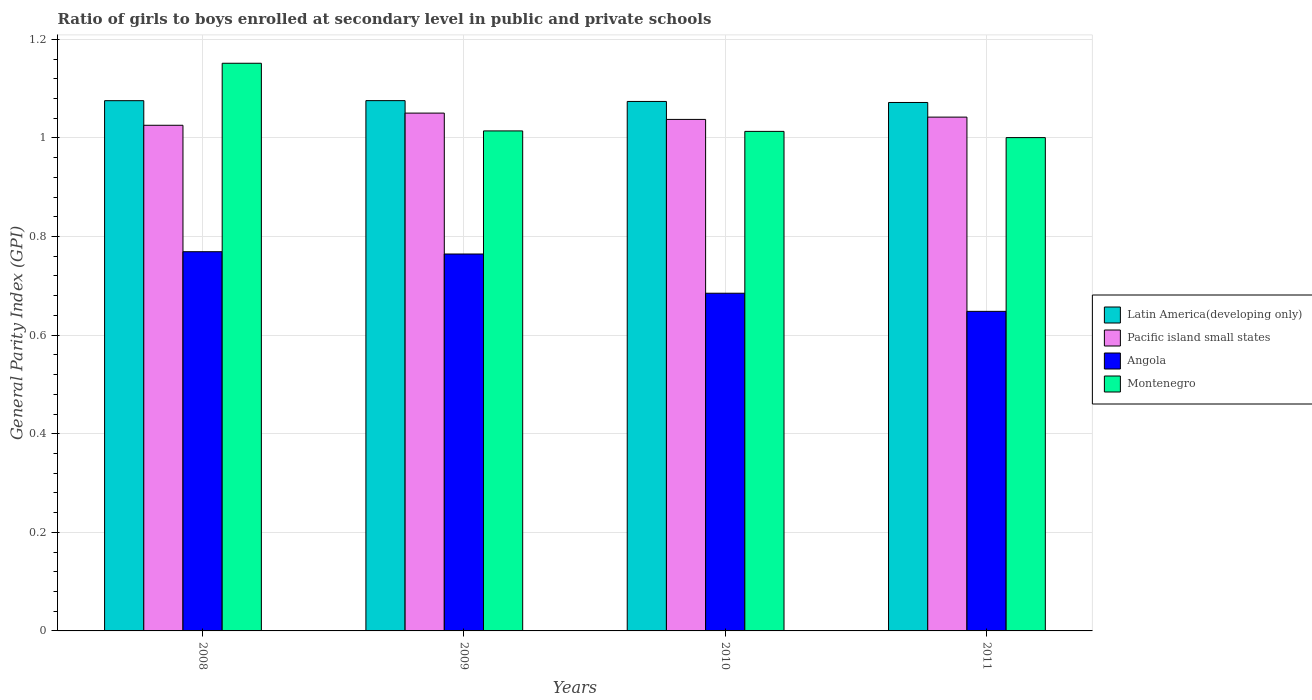Are the number of bars on each tick of the X-axis equal?
Give a very brief answer. Yes. How many bars are there on the 1st tick from the left?
Your response must be concise. 4. How many bars are there on the 3rd tick from the right?
Your answer should be compact. 4. What is the general parity index in Montenegro in 2011?
Make the answer very short. 1. Across all years, what is the maximum general parity index in Angola?
Keep it short and to the point. 0.77. Across all years, what is the minimum general parity index in Latin America(developing only)?
Your answer should be compact. 1.07. In which year was the general parity index in Angola minimum?
Your answer should be compact. 2011. What is the total general parity index in Pacific island small states in the graph?
Keep it short and to the point. 4.16. What is the difference between the general parity index in Montenegro in 2008 and that in 2009?
Your response must be concise. 0.14. What is the difference between the general parity index in Montenegro in 2008 and the general parity index in Angola in 2010?
Your answer should be compact. 0.47. What is the average general parity index in Latin America(developing only) per year?
Your response must be concise. 1.07. In the year 2010, what is the difference between the general parity index in Angola and general parity index in Latin America(developing only)?
Provide a short and direct response. -0.39. What is the ratio of the general parity index in Latin America(developing only) in 2008 to that in 2010?
Your answer should be very brief. 1. Is the difference between the general parity index in Angola in 2008 and 2010 greater than the difference between the general parity index in Latin America(developing only) in 2008 and 2010?
Offer a very short reply. Yes. What is the difference between the highest and the second highest general parity index in Montenegro?
Make the answer very short. 0.14. What is the difference between the highest and the lowest general parity index in Pacific island small states?
Your answer should be compact. 0.02. What does the 4th bar from the left in 2009 represents?
Make the answer very short. Montenegro. What does the 4th bar from the right in 2009 represents?
Provide a succinct answer. Latin America(developing only). How many bars are there?
Your response must be concise. 16. Are all the bars in the graph horizontal?
Your answer should be very brief. No. What is the difference between two consecutive major ticks on the Y-axis?
Provide a succinct answer. 0.2. Are the values on the major ticks of Y-axis written in scientific E-notation?
Your answer should be compact. No. Does the graph contain grids?
Provide a short and direct response. Yes. Where does the legend appear in the graph?
Provide a short and direct response. Center right. How many legend labels are there?
Your response must be concise. 4. What is the title of the graph?
Keep it short and to the point. Ratio of girls to boys enrolled at secondary level in public and private schools. What is the label or title of the X-axis?
Your answer should be compact. Years. What is the label or title of the Y-axis?
Keep it short and to the point. General Parity Index (GPI). What is the General Parity Index (GPI) in Latin America(developing only) in 2008?
Provide a short and direct response. 1.08. What is the General Parity Index (GPI) of Pacific island small states in 2008?
Your answer should be compact. 1.03. What is the General Parity Index (GPI) in Angola in 2008?
Offer a terse response. 0.77. What is the General Parity Index (GPI) of Montenegro in 2008?
Your answer should be compact. 1.15. What is the General Parity Index (GPI) of Latin America(developing only) in 2009?
Your answer should be compact. 1.08. What is the General Parity Index (GPI) in Pacific island small states in 2009?
Keep it short and to the point. 1.05. What is the General Parity Index (GPI) of Angola in 2009?
Your response must be concise. 0.76. What is the General Parity Index (GPI) of Montenegro in 2009?
Offer a terse response. 1.01. What is the General Parity Index (GPI) of Latin America(developing only) in 2010?
Your answer should be compact. 1.07. What is the General Parity Index (GPI) of Pacific island small states in 2010?
Give a very brief answer. 1.04. What is the General Parity Index (GPI) of Angola in 2010?
Ensure brevity in your answer.  0.68. What is the General Parity Index (GPI) of Montenegro in 2010?
Offer a terse response. 1.01. What is the General Parity Index (GPI) in Latin America(developing only) in 2011?
Provide a short and direct response. 1.07. What is the General Parity Index (GPI) of Pacific island small states in 2011?
Give a very brief answer. 1.04. What is the General Parity Index (GPI) of Angola in 2011?
Provide a succinct answer. 0.65. What is the General Parity Index (GPI) in Montenegro in 2011?
Your answer should be very brief. 1. Across all years, what is the maximum General Parity Index (GPI) in Latin America(developing only)?
Ensure brevity in your answer.  1.08. Across all years, what is the maximum General Parity Index (GPI) in Pacific island small states?
Your response must be concise. 1.05. Across all years, what is the maximum General Parity Index (GPI) in Angola?
Your response must be concise. 0.77. Across all years, what is the maximum General Parity Index (GPI) of Montenegro?
Your answer should be compact. 1.15. Across all years, what is the minimum General Parity Index (GPI) in Latin America(developing only)?
Offer a terse response. 1.07. Across all years, what is the minimum General Parity Index (GPI) of Pacific island small states?
Give a very brief answer. 1.03. Across all years, what is the minimum General Parity Index (GPI) of Angola?
Provide a short and direct response. 0.65. Across all years, what is the minimum General Parity Index (GPI) of Montenegro?
Provide a short and direct response. 1. What is the total General Parity Index (GPI) of Latin America(developing only) in the graph?
Offer a very short reply. 4.3. What is the total General Parity Index (GPI) in Pacific island small states in the graph?
Give a very brief answer. 4.16. What is the total General Parity Index (GPI) in Angola in the graph?
Your answer should be very brief. 2.87. What is the total General Parity Index (GPI) in Montenegro in the graph?
Your answer should be very brief. 4.18. What is the difference between the General Parity Index (GPI) in Latin America(developing only) in 2008 and that in 2009?
Offer a very short reply. -0. What is the difference between the General Parity Index (GPI) in Pacific island small states in 2008 and that in 2009?
Your response must be concise. -0.02. What is the difference between the General Parity Index (GPI) in Angola in 2008 and that in 2009?
Provide a succinct answer. 0. What is the difference between the General Parity Index (GPI) of Montenegro in 2008 and that in 2009?
Offer a terse response. 0.14. What is the difference between the General Parity Index (GPI) of Latin America(developing only) in 2008 and that in 2010?
Give a very brief answer. 0. What is the difference between the General Parity Index (GPI) of Pacific island small states in 2008 and that in 2010?
Give a very brief answer. -0.01. What is the difference between the General Parity Index (GPI) in Angola in 2008 and that in 2010?
Keep it short and to the point. 0.08. What is the difference between the General Parity Index (GPI) in Montenegro in 2008 and that in 2010?
Offer a very short reply. 0.14. What is the difference between the General Parity Index (GPI) of Latin America(developing only) in 2008 and that in 2011?
Offer a very short reply. 0. What is the difference between the General Parity Index (GPI) of Pacific island small states in 2008 and that in 2011?
Ensure brevity in your answer.  -0.02. What is the difference between the General Parity Index (GPI) in Angola in 2008 and that in 2011?
Your answer should be compact. 0.12. What is the difference between the General Parity Index (GPI) of Montenegro in 2008 and that in 2011?
Keep it short and to the point. 0.15. What is the difference between the General Parity Index (GPI) in Latin America(developing only) in 2009 and that in 2010?
Give a very brief answer. 0. What is the difference between the General Parity Index (GPI) in Pacific island small states in 2009 and that in 2010?
Your response must be concise. 0.01. What is the difference between the General Parity Index (GPI) of Angola in 2009 and that in 2010?
Give a very brief answer. 0.08. What is the difference between the General Parity Index (GPI) of Latin America(developing only) in 2009 and that in 2011?
Make the answer very short. 0. What is the difference between the General Parity Index (GPI) in Pacific island small states in 2009 and that in 2011?
Ensure brevity in your answer.  0.01. What is the difference between the General Parity Index (GPI) in Angola in 2009 and that in 2011?
Offer a terse response. 0.12. What is the difference between the General Parity Index (GPI) in Montenegro in 2009 and that in 2011?
Offer a very short reply. 0.01. What is the difference between the General Parity Index (GPI) of Latin America(developing only) in 2010 and that in 2011?
Make the answer very short. 0. What is the difference between the General Parity Index (GPI) in Pacific island small states in 2010 and that in 2011?
Provide a short and direct response. -0. What is the difference between the General Parity Index (GPI) of Angola in 2010 and that in 2011?
Your answer should be compact. 0.04. What is the difference between the General Parity Index (GPI) of Montenegro in 2010 and that in 2011?
Provide a short and direct response. 0.01. What is the difference between the General Parity Index (GPI) of Latin America(developing only) in 2008 and the General Parity Index (GPI) of Pacific island small states in 2009?
Keep it short and to the point. 0.03. What is the difference between the General Parity Index (GPI) in Latin America(developing only) in 2008 and the General Parity Index (GPI) in Angola in 2009?
Offer a very short reply. 0.31. What is the difference between the General Parity Index (GPI) in Latin America(developing only) in 2008 and the General Parity Index (GPI) in Montenegro in 2009?
Your answer should be compact. 0.06. What is the difference between the General Parity Index (GPI) in Pacific island small states in 2008 and the General Parity Index (GPI) in Angola in 2009?
Ensure brevity in your answer.  0.26. What is the difference between the General Parity Index (GPI) of Pacific island small states in 2008 and the General Parity Index (GPI) of Montenegro in 2009?
Your answer should be very brief. 0.01. What is the difference between the General Parity Index (GPI) of Angola in 2008 and the General Parity Index (GPI) of Montenegro in 2009?
Give a very brief answer. -0.24. What is the difference between the General Parity Index (GPI) of Latin America(developing only) in 2008 and the General Parity Index (GPI) of Pacific island small states in 2010?
Provide a succinct answer. 0.04. What is the difference between the General Parity Index (GPI) in Latin America(developing only) in 2008 and the General Parity Index (GPI) in Angola in 2010?
Offer a very short reply. 0.39. What is the difference between the General Parity Index (GPI) in Latin America(developing only) in 2008 and the General Parity Index (GPI) in Montenegro in 2010?
Ensure brevity in your answer.  0.06. What is the difference between the General Parity Index (GPI) of Pacific island small states in 2008 and the General Parity Index (GPI) of Angola in 2010?
Offer a very short reply. 0.34. What is the difference between the General Parity Index (GPI) in Pacific island small states in 2008 and the General Parity Index (GPI) in Montenegro in 2010?
Offer a terse response. 0.01. What is the difference between the General Parity Index (GPI) in Angola in 2008 and the General Parity Index (GPI) in Montenegro in 2010?
Provide a short and direct response. -0.24. What is the difference between the General Parity Index (GPI) in Latin America(developing only) in 2008 and the General Parity Index (GPI) in Pacific island small states in 2011?
Make the answer very short. 0.03. What is the difference between the General Parity Index (GPI) in Latin America(developing only) in 2008 and the General Parity Index (GPI) in Angola in 2011?
Your answer should be compact. 0.43. What is the difference between the General Parity Index (GPI) in Latin America(developing only) in 2008 and the General Parity Index (GPI) in Montenegro in 2011?
Your answer should be compact. 0.07. What is the difference between the General Parity Index (GPI) of Pacific island small states in 2008 and the General Parity Index (GPI) of Angola in 2011?
Offer a very short reply. 0.38. What is the difference between the General Parity Index (GPI) of Pacific island small states in 2008 and the General Parity Index (GPI) of Montenegro in 2011?
Provide a short and direct response. 0.03. What is the difference between the General Parity Index (GPI) in Angola in 2008 and the General Parity Index (GPI) in Montenegro in 2011?
Make the answer very short. -0.23. What is the difference between the General Parity Index (GPI) of Latin America(developing only) in 2009 and the General Parity Index (GPI) of Pacific island small states in 2010?
Offer a terse response. 0.04. What is the difference between the General Parity Index (GPI) in Latin America(developing only) in 2009 and the General Parity Index (GPI) in Angola in 2010?
Ensure brevity in your answer.  0.39. What is the difference between the General Parity Index (GPI) in Latin America(developing only) in 2009 and the General Parity Index (GPI) in Montenegro in 2010?
Offer a terse response. 0.06. What is the difference between the General Parity Index (GPI) of Pacific island small states in 2009 and the General Parity Index (GPI) of Angola in 2010?
Your answer should be very brief. 0.37. What is the difference between the General Parity Index (GPI) in Pacific island small states in 2009 and the General Parity Index (GPI) in Montenegro in 2010?
Provide a short and direct response. 0.04. What is the difference between the General Parity Index (GPI) in Angola in 2009 and the General Parity Index (GPI) in Montenegro in 2010?
Keep it short and to the point. -0.25. What is the difference between the General Parity Index (GPI) of Latin America(developing only) in 2009 and the General Parity Index (GPI) of Pacific island small states in 2011?
Provide a succinct answer. 0.03. What is the difference between the General Parity Index (GPI) in Latin America(developing only) in 2009 and the General Parity Index (GPI) in Angola in 2011?
Your answer should be compact. 0.43. What is the difference between the General Parity Index (GPI) of Latin America(developing only) in 2009 and the General Parity Index (GPI) of Montenegro in 2011?
Keep it short and to the point. 0.07. What is the difference between the General Parity Index (GPI) of Pacific island small states in 2009 and the General Parity Index (GPI) of Angola in 2011?
Ensure brevity in your answer.  0.4. What is the difference between the General Parity Index (GPI) in Pacific island small states in 2009 and the General Parity Index (GPI) in Montenegro in 2011?
Your answer should be very brief. 0.05. What is the difference between the General Parity Index (GPI) of Angola in 2009 and the General Parity Index (GPI) of Montenegro in 2011?
Provide a short and direct response. -0.24. What is the difference between the General Parity Index (GPI) of Latin America(developing only) in 2010 and the General Parity Index (GPI) of Pacific island small states in 2011?
Give a very brief answer. 0.03. What is the difference between the General Parity Index (GPI) in Latin America(developing only) in 2010 and the General Parity Index (GPI) in Angola in 2011?
Offer a very short reply. 0.43. What is the difference between the General Parity Index (GPI) in Latin America(developing only) in 2010 and the General Parity Index (GPI) in Montenegro in 2011?
Offer a terse response. 0.07. What is the difference between the General Parity Index (GPI) in Pacific island small states in 2010 and the General Parity Index (GPI) in Angola in 2011?
Make the answer very short. 0.39. What is the difference between the General Parity Index (GPI) in Pacific island small states in 2010 and the General Parity Index (GPI) in Montenegro in 2011?
Offer a terse response. 0.04. What is the difference between the General Parity Index (GPI) in Angola in 2010 and the General Parity Index (GPI) in Montenegro in 2011?
Provide a short and direct response. -0.32. What is the average General Parity Index (GPI) in Latin America(developing only) per year?
Make the answer very short. 1.07. What is the average General Parity Index (GPI) in Pacific island small states per year?
Give a very brief answer. 1.04. What is the average General Parity Index (GPI) of Angola per year?
Keep it short and to the point. 0.72. What is the average General Parity Index (GPI) of Montenegro per year?
Provide a short and direct response. 1.04. In the year 2008, what is the difference between the General Parity Index (GPI) in Latin America(developing only) and General Parity Index (GPI) in Pacific island small states?
Make the answer very short. 0.05. In the year 2008, what is the difference between the General Parity Index (GPI) in Latin America(developing only) and General Parity Index (GPI) in Angola?
Give a very brief answer. 0.31. In the year 2008, what is the difference between the General Parity Index (GPI) of Latin America(developing only) and General Parity Index (GPI) of Montenegro?
Offer a terse response. -0.08. In the year 2008, what is the difference between the General Parity Index (GPI) of Pacific island small states and General Parity Index (GPI) of Angola?
Offer a terse response. 0.26. In the year 2008, what is the difference between the General Parity Index (GPI) in Pacific island small states and General Parity Index (GPI) in Montenegro?
Your answer should be compact. -0.13. In the year 2008, what is the difference between the General Parity Index (GPI) of Angola and General Parity Index (GPI) of Montenegro?
Your answer should be compact. -0.38. In the year 2009, what is the difference between the General Parity Index (GPI) in Latin America(developing only) and General Parity Index (GPI) in Pacific island small states?
Give a very brief answer. 0.03. In the year 2009, what is the difference between the General Parity Index (GPI) of Latin America(developing only) and General Parity Index (GPI) of Angola?
Offer a very short reply. 0.31. In the year 2009, what is the difference between the General Parity Index (GPI) in Latin America(developing only) and General Parity Index (GPI) in Montenegro?
Provide a short and direct response. 0.06. In the year 2009, what is the difference between the General Parity Index (GPI) of Pacific island small states and General Parity Index (GPI) of Angola?
Provide a succinct answer. 0.29. In the year 2009, what is the difference between the General Parity Index (GPI) in Pacific island small states and General Parity Index (GPI) in Montenegro?
Keep it short and to the point. 0.04. In the year 2009, what is the difference between the General Parity Index (GPI) in Angola and General Parity Index (GPI) in Montenegro?
Your answer should be compact. -0.25. In the year 2010, what is the difference between the General Parity Index (GPI) in Latin America(developing only) and General Parity Index (GPI) in Pacific island small states?
Provide a short and direct response. 0.04. In the year 2010, what is the difference between the General Parity Index (GPI) of Latin America(developing only) and General Parity Index (GPI) of Angola?
Provide a short and direct response. 0.39. In the year 2010, what is the difference between the General Parity Index (GPI) in Latin America(developing only) and General Parity Index (GPI) in Montenegro?
Provide a succinct answer. 0.06. In the year 2010, what is the difference between the General Parity Index (GPI) in Pacific island small states and General Parity Index (GPI) in Angola?
Your answer should be very brief. 0.35. In the year 2010, what is the difference between the General Parity Index (GPI) in Pacific island small states and General Parity Index (GPI) in Montenegro?
Your answer should be compact. 0.02. In the year 2010, what is the difference between the General Parity Index (GPI) of Angola and General Parity Index (GPI) of Montenegro?
Offer a terse response. -0.33. In the year 2011, what is the difference between the General Parity Index (GPI) in Latin America(developing only) and General Parity Index (GPI) in Pacific island small states?
Your response must be concise. 0.03. In the year 2011, what is the difference between the General Parity Index (GPI) in Latin America(developing only) and General Parity Index (GPI) in Angola?
Offer a terse response. 0.42. In the year 2011, what is the difference between the General Parity Index (GPI) of Latin America(developing only) and General Parity Index (GPI) of Montenegro?
Your answer should be very brief. 0.07. In the year 2011, what is the difference between the General Parity Index (GPI) of Pacific island small states and General Parity Index (GPI) of Angola?
Offer a very short reply. 0.39. In the year 2011, what is the difference between the General Parity Index (GPI) in Pacific island small states and General Parity Index (GPI) in Montenegro?
Offer a very short reply. 0.04. In the year 2011, what is the difference between the General Parity Index (GPI) in Angola and General Parity Index (GPI) in Montenegro?
Ensure brevity in your answer.  -0.35. What is the ratio of the General Parity Index (GPI) in Pacific island small states in 2008 to that in 2009?
Ensure brevity in your answer.  0.98. What is the ratio of the General Parity Index (GPI) of Montenegro in 2008 to that in 2009?
Offer a terse response. 1.14. What is the ratio of the General Parity Index (GPI) in Latin America(developing only) in 2008 to that in 2010?
Your answer should be very brief. 1. What is the ratio of the General Parity Index (GPI) in Pacific island small states in 2008 to that in 2010?
Provide a short and direct response. 0.99. What is the ratio of the General Parity Index (GPI) in Angola in 2008 to that in 2010?
Your answer should be very brief. 1.12. What is the ratio of the General Parity Index (GPI) of Montenegro in 2008 to that in 2010?
Keep it short and to the point. 1.14. What is the ratio of the General Parity Index (GPI) of Pacific island small states in 2008 to that in 2011?
Make the answer very short. 0.98. What is the ratio of the General Parity Index (GPI) in Angola in 2008 to that in 2011?
Provide a succinct answer. 1.19. What is the ratio of the General Parity Index (GPI) in Montenegro in 2008 to that in 2011?
Keep it short and to the point. 1.15. What is the ratio of the General Parity Index (GPI) of Pacific island small states in 2009 to that in 2010?
Ensure brevity in your answer.  1.01. What is the ratio of the General Parity Index (GPI) of Angola in 2009 to that in 2010?
Ensure brevity in your answer.  1.12. What is the ratio of the General Parity Index (GPI) in Montenegro in 2009 to that in 2010?
Your response must be concise. 1. What is the ratio of the General Parity Index (GPI) of Pacific island small states in 2009 to that in 2011?
Offer a very short reply. 1.01. What is the ratio of the General Parity Index (GPI) of Angola in 2009 to that in 2011?
Make the answer very short. 1.18. What is the ratio of the General Parity Index (GPI) in Montenegro in 2009 to that in 2011?
Keep it short and to the point. 1.01. What is the ratio of the General Parity Index (GPI) in Angola in 2010 to that in 2011?
Provide a succinct answer. 1.06. What is the ratio of the General Parity Index (GPI) in Montenegro in 2010 to that in 2011?
Provide a short and direct response. 1.01. What is the difference between the highest and the second highest General Parity Index (GPI) in Pacific island small states?
Keep it short and to the point. 0.01. What is the difference between the highest and the second highest General Parity Index (GPI) in Angola?
Your response must be concise. 0. What is the difference between the highest and the second highest General Parity Index (GPI) of Montenegro?
Your answer should be very brief. 0.14. What is the difference between the highest and the lowest General Parity Index (GPI) of Latin America(developing only)?
Give a very brief answer. 0. What is the difference between the highest and the lowest General Parity Index (GPI) in Pacific island small states?
Ensure brevity in your answer.  0.02. What is the difference between the highest and the lowest General Parity Index (GPI) of Angola?
Offer a terse response. 0.12. What is the difference between the highest and the lowest General Parity Index (GPI) in Montenegro?
Provide a succinct answer. 0.15. 